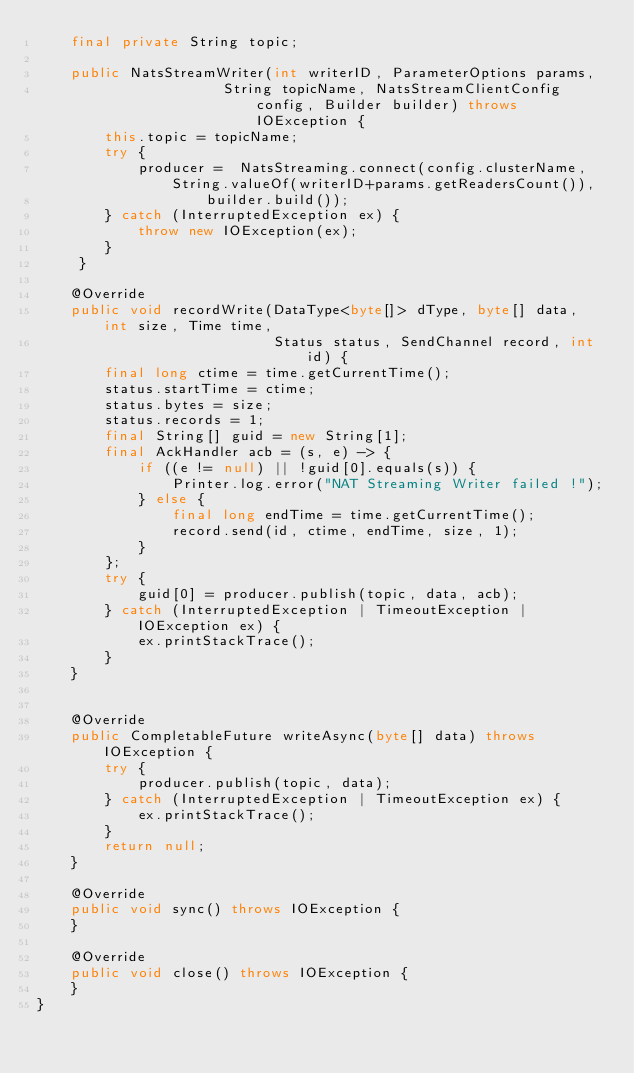<code> <loc_0><loc_0><loc_500><loc_500><_Java_>    final private String topic;

    public NatsStreamWriter(int writerID, ParameterOptions params,
                      String topicName, NatsStreamClientConfig config, Builder builder) throws IOException {
        this.topic = topicName;
        try {
            producer =  NatsStreaming.connect(config.clusterName, String.valueOf(writerID+params.getReadersCount()),
                    builder.build());
        } catch (InterruptedException ex) {
            throw new IOException(ex);
        }
     }

    @Override
    public void recordWrite(DataType<byte[]> dType, byte[] data, int size, Time time,
                            Status status, SendChannel record, int id) {
        final long ctime = time.getCurrentTime();
        status.startTime = ctime;
        status.bytes = size;
        status.records = 1;
        final String[] guid = new String[1];
        final AckHandler acb = (s, e) -> {
            if ((e != null) || !guid[0].equals(s)) {
                Printer.log.error("NAT Streaming Writer failed !");
            } else {
                final long endTime = time.getCurrentTime();
                record.send(id, ctime, endTime, size, 1);
            }
        };
        try {
            guid[0] = producer.publish(topic, data, acb);
        } catch (InterruptedException | TimeoutException | IOException ex) {
            ex.printStackTrace();
        }
    }


    @Override
    public CompletableFuture writeAsync(byte[] data) throws IOException {
        try {
            producer.publish(topic, data);
        } catch (InterruptedException | TimeoutException ex) {
            ex.printStackTrace();
        }
        return null;
    }

    @Override
    public void sync() throws IOException {
    }

    @Override
    public void close() throws IOException {
    }
}</code> 